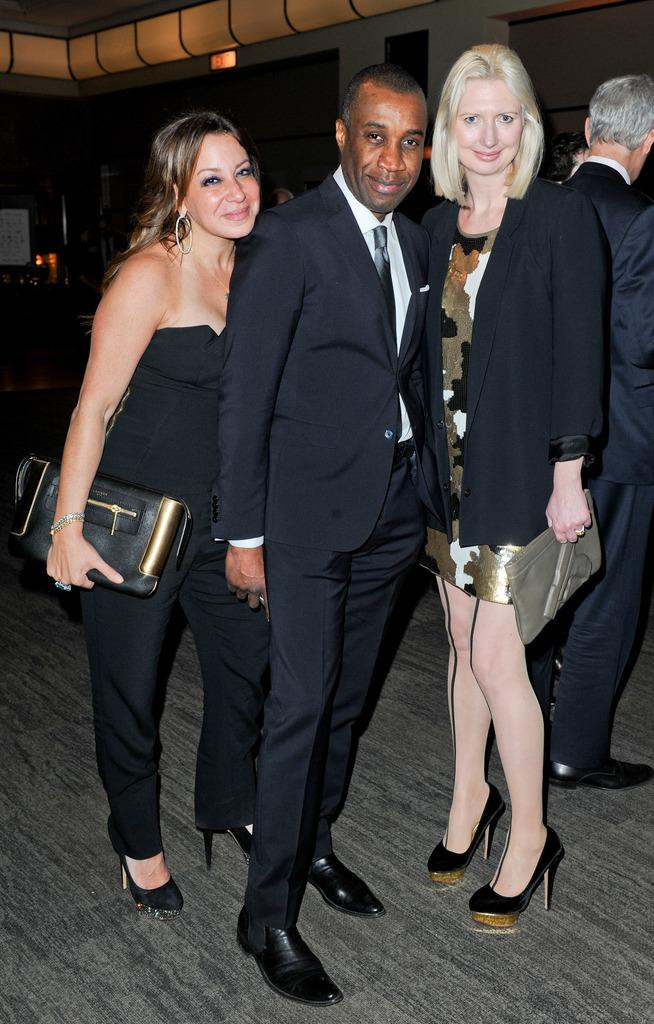What is visible above the people in the image? There is a ceiling visible in the image. How many people can be seen in the image? There are three people standing in the image. What is the facial expression of the people in the image? The people are smiling. What are the women holding in their hands? The women are holding bags in their hands. Where are the people standing in the image? The people are standing on the floor in the image. What type of feast is being prepared in the image? There is no feast or preparation for a feast visible in the image. What furniture can be seen in the image? There is no furniture present in the image. 